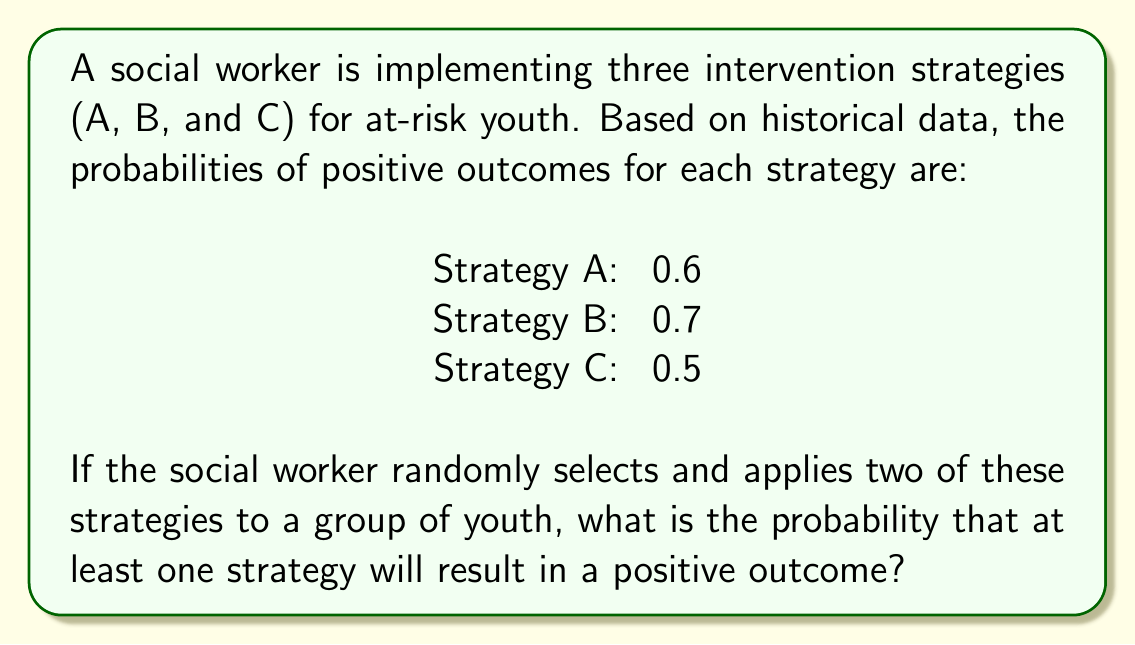What is the answer to this math problem? Let's approach this step-by-step:

1) First, we need to calculate the probability of the complement event: the probability that neither strategy results in a positive outcome.

2) For any two strategies selected, the probability of both failing is the product of their individual failure probabilities.

3) The failure probabilities are:
   Strategy A: $1 - 0.6 = 0.4$
   Strategy B: $1 - 0.7 = 0.3$
   Strategy C: $1 - 0.5 = 0.5$

4) There are three possible combinations of two strategies:
   A and B: $P(\text{both fail}) = 0.4 \times 0.3 = 0.12$
   A and C: $P(\text{both fail}) = 0.4 \times 0.5 = 0.20$
   B and C: $P(\text{both fail}) = 0.3 \times 0.5 = 0.15$

5) The probability of selecting each combination is $\frac{1}{3}$, so the total probability of both selected strategies failing is:

   $$P(\text{both fail}) = \frac{1}{3}(0.12 + 0.20 + 0.15) = \frac{0.47}{3} = \frac{47}{300}$$

6) Therefore, the probability of at least one strategy resulting in a positive outcome is:

   $$P(\text{at least one succeeds}) = 1 - P(\text{both fail}) = 1 - \frac{47}{300} = \frac{253}{300}$$
Answer: $\frac{253}{300}$ or approximately 0.8433 